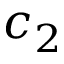<formula> <loc_0><loc_0><loc_500><loc_500>c _ { 2 }</formula> 